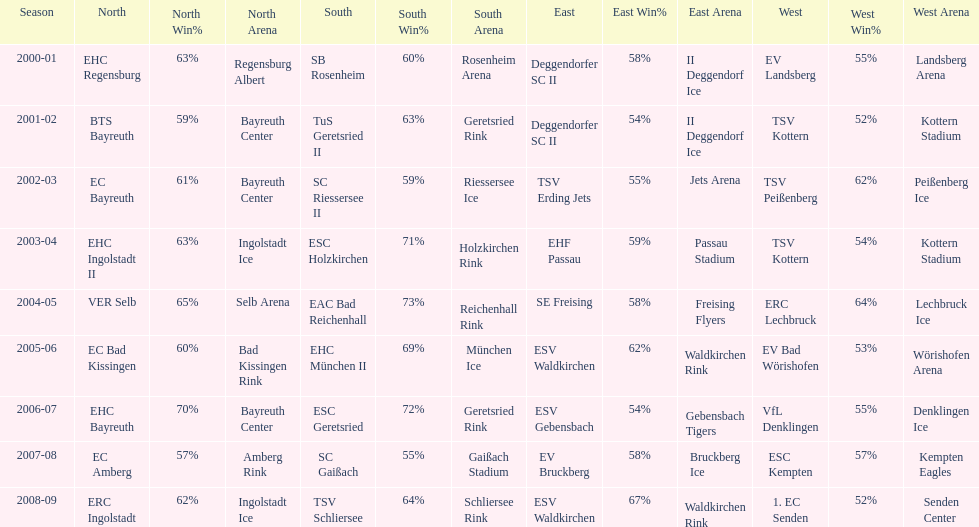What was the first club for the north in the 2000's? EHC Regensburg. 